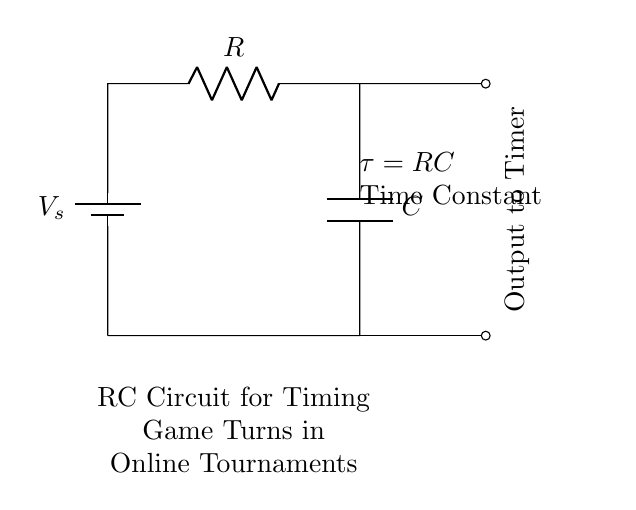What are the components in this circuit? The circuit contains a battery, a resistor, and a capacitor, as indicated by their respective symbols.
Answer: battery, resistor, capacitor What is the function of the capacitor in this circuit? The capacitor stores energy and controls the timing by charging and discharging, which is essential for timing game turns.
Answer: timing What is the time constant of this circuit? The time constant is represented by the product of the resistance and capacitance values and is given by the formula tau equals RC.
Answer: tau = RC What happens when the resistor value increases? Increasing the resistor value will increase the time constant, leading to a longer duration for the capacitor to charge or discharge, thus increasing the game turn timing.
Answer: longer timing How are the battery and components connected? The battery is connected in series with the resistor and capacitor, creating a closed loop that allows current to flow through all components.
Answer: series connection What would the output of this circuit be used for? The output can be used as a timer signal to indicate when the game turn is over and the next player can take their turn.
Answer: output to timer 